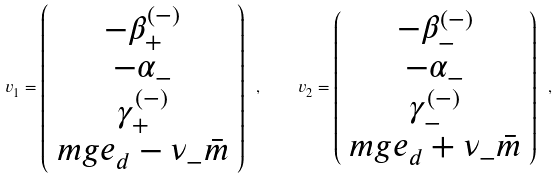Convert formula to latex. <formula><loc_0><loc_0><loc_500><loc_500>v _ { 1 } = \left ( \begin{array} { c } - \beta _ { + } ^ { ( - ) } \\ - \alpha _ { - } \\ \gamma _ { + } ^ { ( - ) } \\ m g e _ { d } - \nu _ { - } \bar { m } \end{array} \right ) \ , \quad v _ { 2 } = \left ( \begin{array} { c } - \beta _ { - } ^ { ( - ) } \\ - \alpha _ { - } \\ \gamma _ { - } ^ { ( - ) } \\ m g e _ { d } + \nu _ { - } \bar { m } \end{array} \right ) \ ,</formula> 